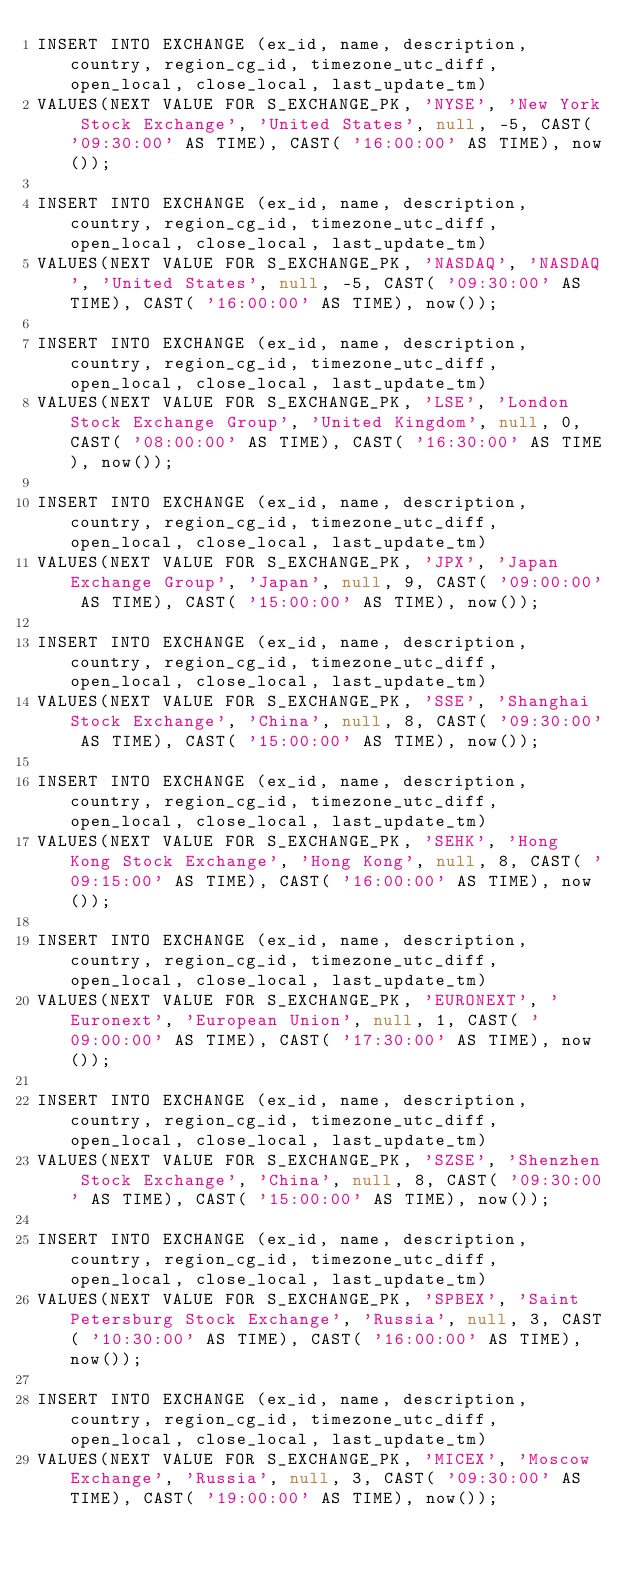Convert code to text. <code><loc_0><loc_0><loc_500><loc_500><_SQL_>INSERT INTO EXCHANGE (ex_id, name, description, country, region_cg_id, timezone_utc_diff, open_local, close_local, last_update_tm)
VALUES(NEXT VALUE FOR S_EXCHANGE_PK, 'NYSE', 'New York Stock Exchange', 'United States', null, -5, CAST( '09:30:00' AS TIME), CAST( '16:00:00' AS TIME), now());

INSERT INTO EXCHANGE (ex_id, name, description, country, region_cg_id, timezone_utc_diff, open_local, close_local, last_update_tm)
VALUES(NEXT VALUE FOR S_EXCHANGE_PK, 'NASDAQ', 'NASDAQ', 'United States', null, -5, CAST( '09:30:00' AS TIME), CAST( '16:00:00' AS TIME), now());

INSERT INTO EXCHANGE (ex_id, name, description, country, region_cg_id, timezone_utc_diff, open_local, close_local, last_update_tm)
VALUES(NEXT VALUE FOR S_EXCHANGE_PK, 'LSE', 'London Stock Exchange Group', 'United Kingdom', null, 0, CAST( '08:00:00' AS TIME), CAST( '16:30:00' AS TIME), now());

INSERT INTO EXCHANGE (ex_id, name, description, country, region_cg_id, timezone_utc_diff, open_local, close_local, last_update_tm)
VALUES(NEXT VALUE FOR S_EXCHANGE_PK, 'JPX', 'Japan Exchange Group', 'Japan', null, 9, CAST( '09:00:00' AS TIME), CAST( '15:00:00' AS TIME), now());

INSERT INTO EXCHANGE (ex_id, name, description, country, region_cg_id, timezone_utc_diff, open_local, close_local, last_update_tm)
VALUES(NEXT VALUE FOR S_EXCHANGE_PK, 'SSE', 'Shanghai Stock Exchange', 'China', null, 8, CAST( '09:30:00' AS TIME), CAST( '15:00:00' AS TIME), now());

INSERT INTO EXCHANGE (ex_id, name, description, country, region_cg_id, timezone_utc_diff, open_local, close_local, last_update_tm)
VALUES(NEXT VALUE FOR S_EXCHANGE_PK, 'SEHK', 'Hong Kong Stock Exchange', 'Hong Kong', null, 8, CAST( '09:15:00' AS TIME), CAST( '16:00:00' AS TIME), now());

INSERT INTO EXCHANGE (ex_id, name, description, country, region_cg_id, timezone_utc_diff, open_local, close_local, last_update_tm)
VALUES(NEXT VALUE FOR S_EXCHANGE_PK, 'EURONEXT', 'Euronext', 'European Union', null, 1, CAST( '09:00:00' AS TIME), CAST( '17:30:00' AS TIME), now());

INSERT INTO EXCHANGE (ex_id, name, description, country, region_cg_id, timezone_utc_diff, open_local, close_local, last_update_tm)
VALUES(NEXT VALUE FOR S_EXCHANGE_PK, 'SZSE', 'Shenzhen Stock Exchange', 'China', null, 8, CAST( '09:30:00' AS TIME), CAST( '15:00:00' AS TIME), now());

INSERT INTO EXCHANGE (ex_id, name, description, country, region_cg_id, timezone_utc_diff, open_local, close_local, last_update_tm)
VALUES(NEXT VALUE FOR S_EXCHANGE_PK, 'SPBEX', 'Saint Petersburg Stock Exchange', 'Russia', null, 3, CAST( '10:30:00' AS TIME), CAST( '16:00:00' AS TIME), now());

INSERT INTO EXCHANGE (ex_id, name, description, country, region_cg_id, timezone_utc_diff, open_local, close_local, last_update_tm)
VALUES(NEXT VALUE FOR S_EXCHANGE_PK, 'MICEX', 'Moscow Exchange', 'Russia', null, 3, CAST( '09:30:00' AS TIME), CAST( '19:00:00' AS TIME), now());
</code> 